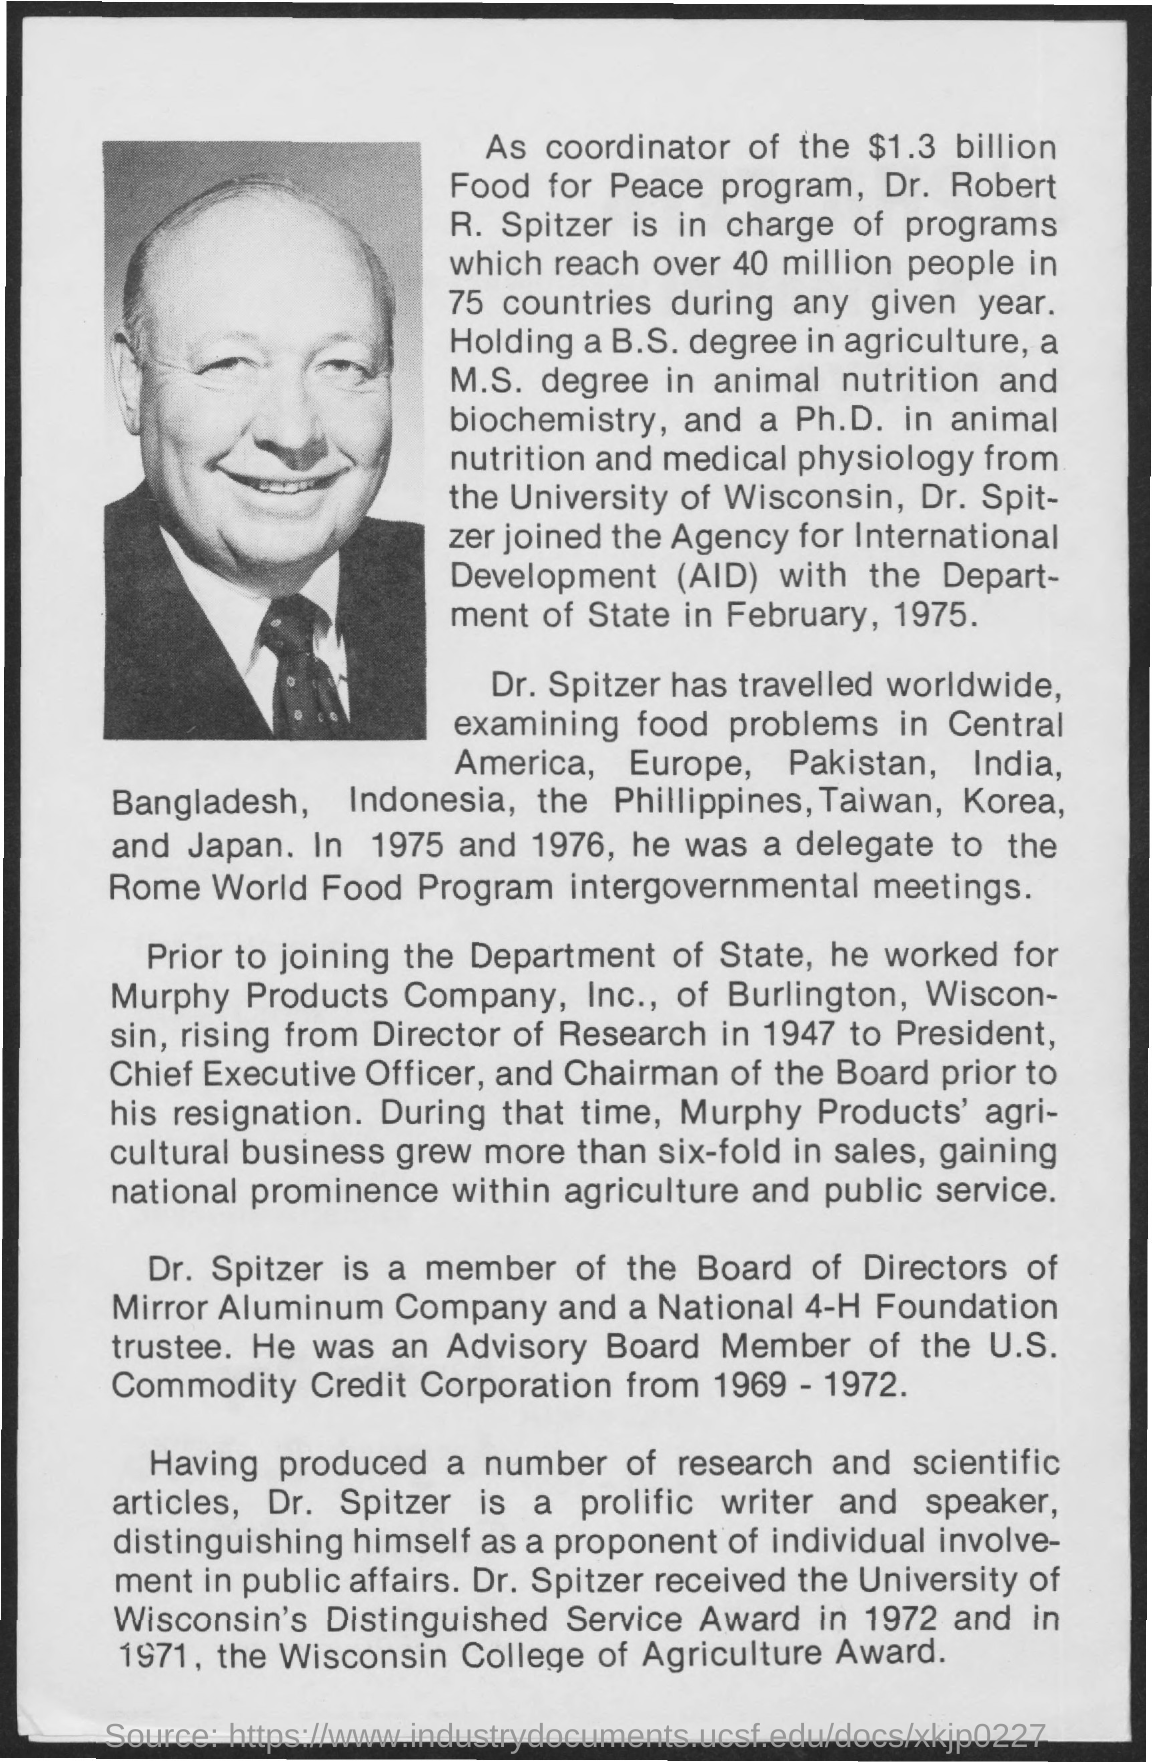What is the fullform of AID?
Keep it short and to the point. Agency for international development. During which period, Dr. Spitzer was an Advisory Board Member of the U.S. Commodity Corporation?
Your answer should be very brief. From 1969 - 1972. In which year, Dr. Spitzer was a delegate to the Rome World Food Program intergovernmental meetings?
Offer a terse response. 1975 and 1976. When did Dr. Spitzer joined the Agency for International Development (AID) with the Department of State?
Make the answer very short. February, 1975. 